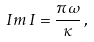Convert formula to latex. <formula><loc_0><loc_0><loc_500><loc_500>I m \, I = \frac { \pi \omega } { \kappa } \, ,</formula> 